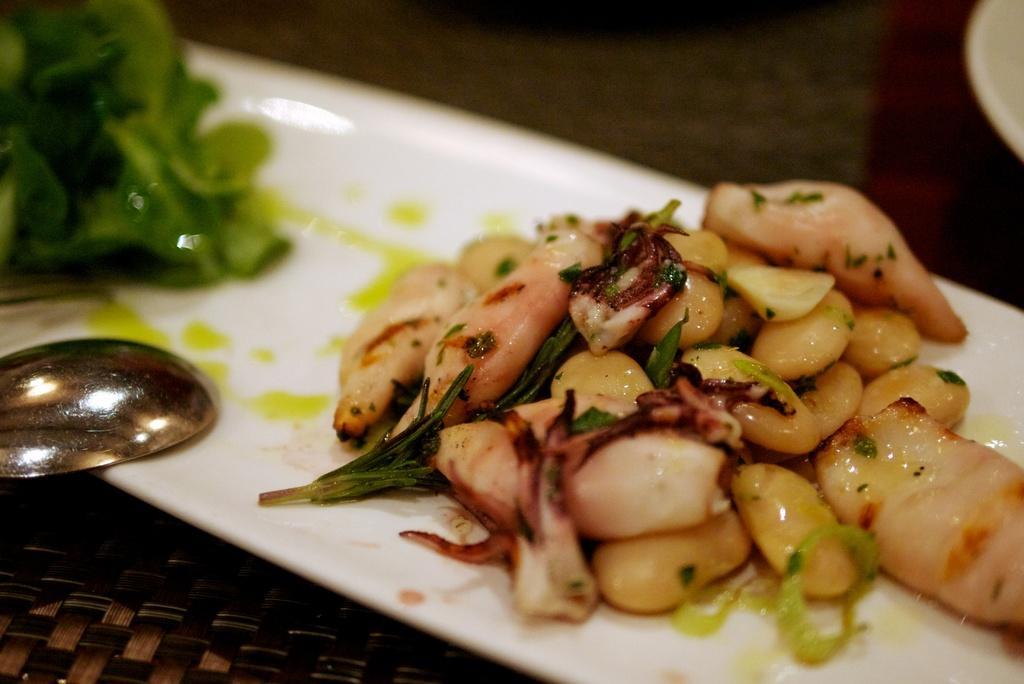In one or two sentences, can you explain what this image depicts? In this picture, we see a white tray containing food, spoon and leafy vegetables. This tray is placed on the brown table. In the background, it is brown in color and it is blurred. 